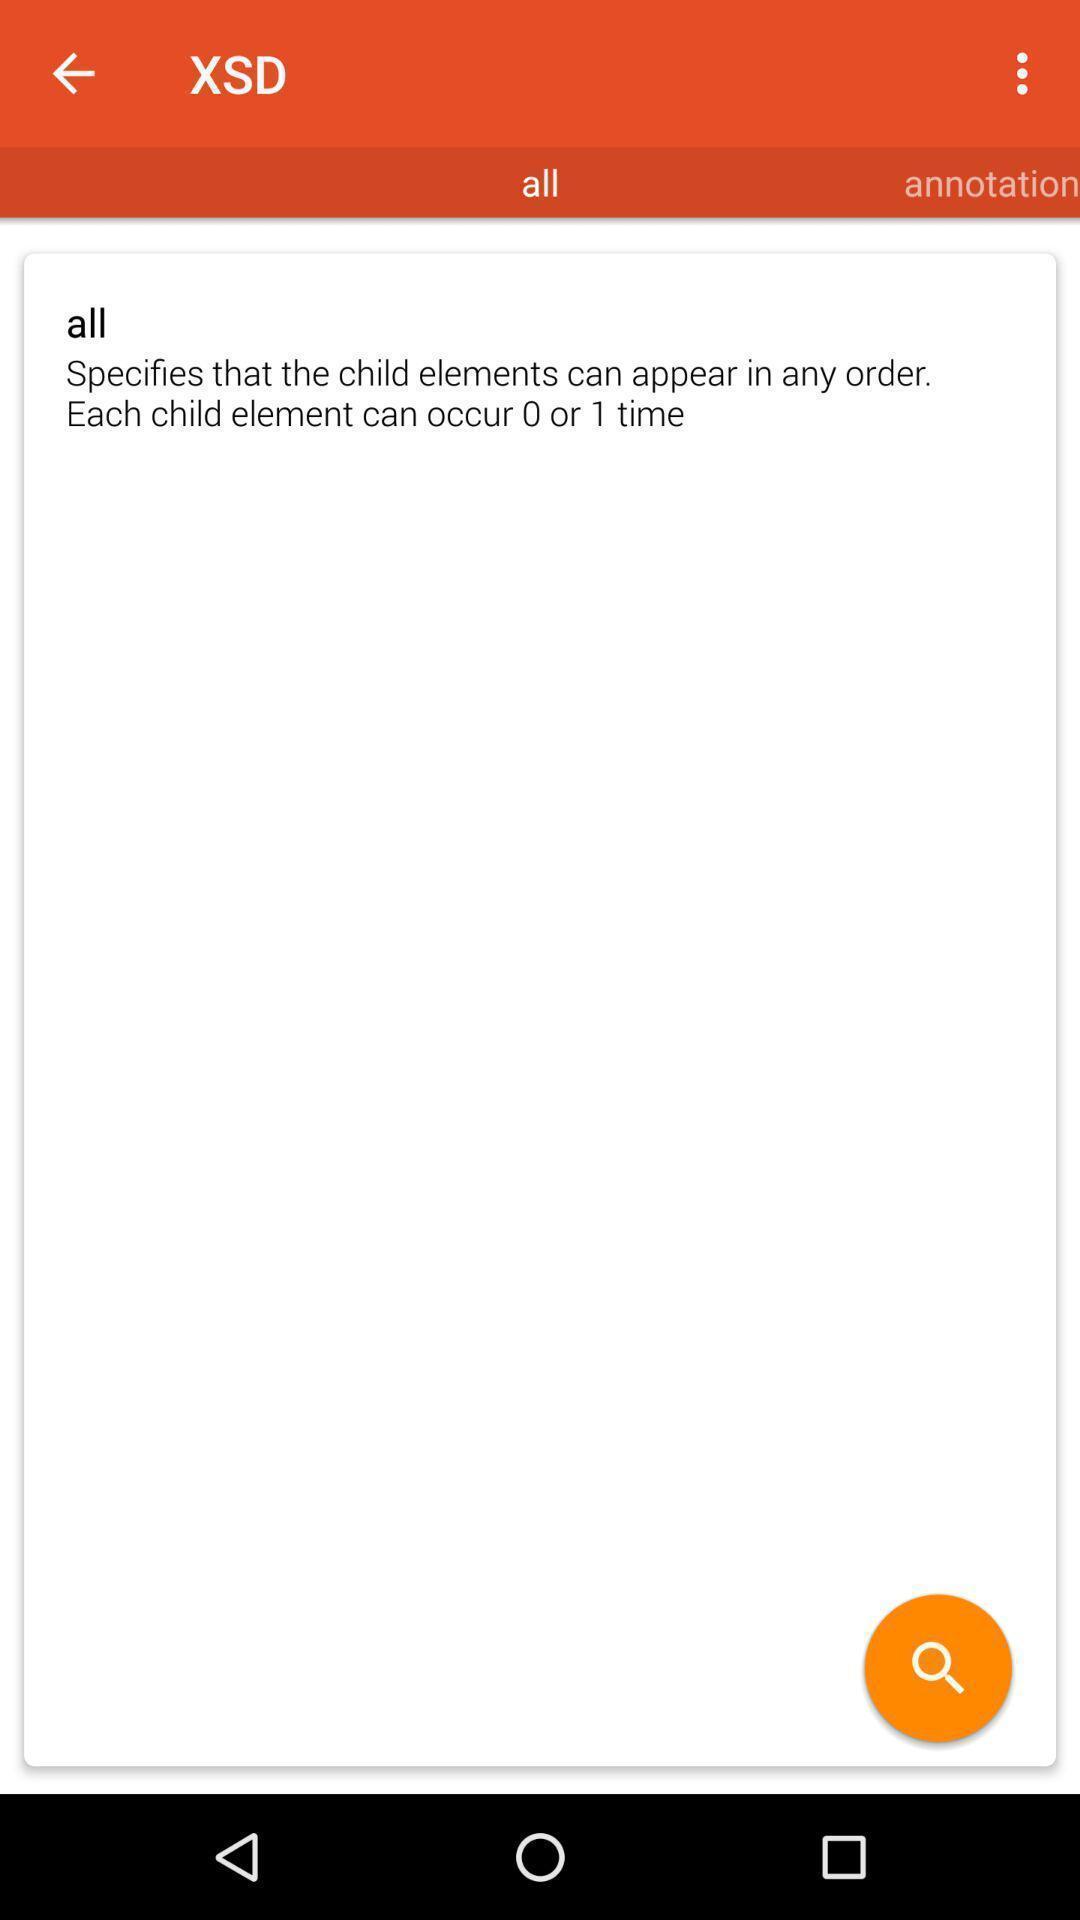Describe this image in words. Page displaying texts with a search icon. 